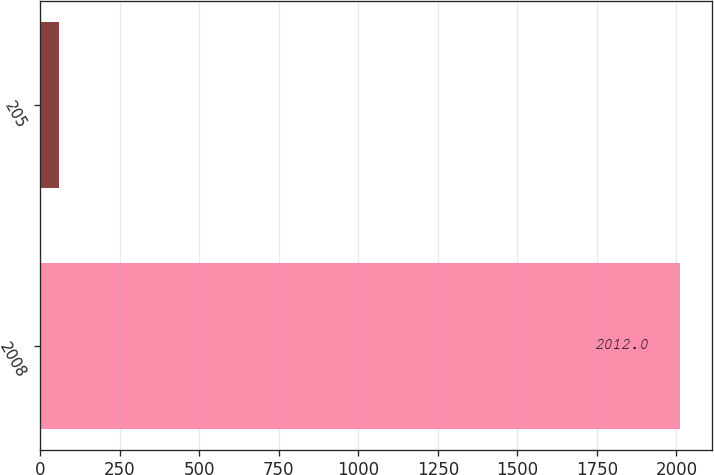Convert chart to OTSL. <chart><loc_0><loc_0><loc_500><loc_500><bar_chart><fcel>2008<fcel>205<nl><fcel>2012<fcel>60<nl></chart> 